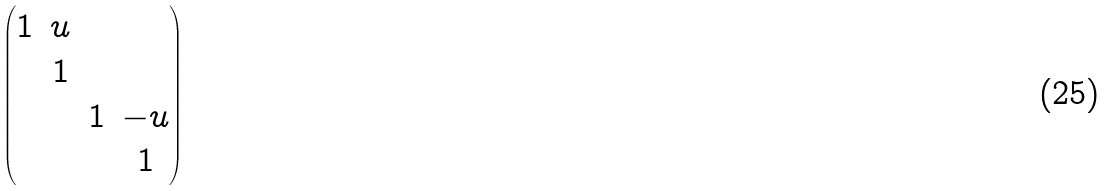Convert formula to latex. <formula><loc_0><loc_0><loc_500><loc_500>\begin{pmatrix} 1 & u & & \\ & 1 & & \\ & & 1 & - u \\ & & & 1 \end{pmatrix}</formula> 